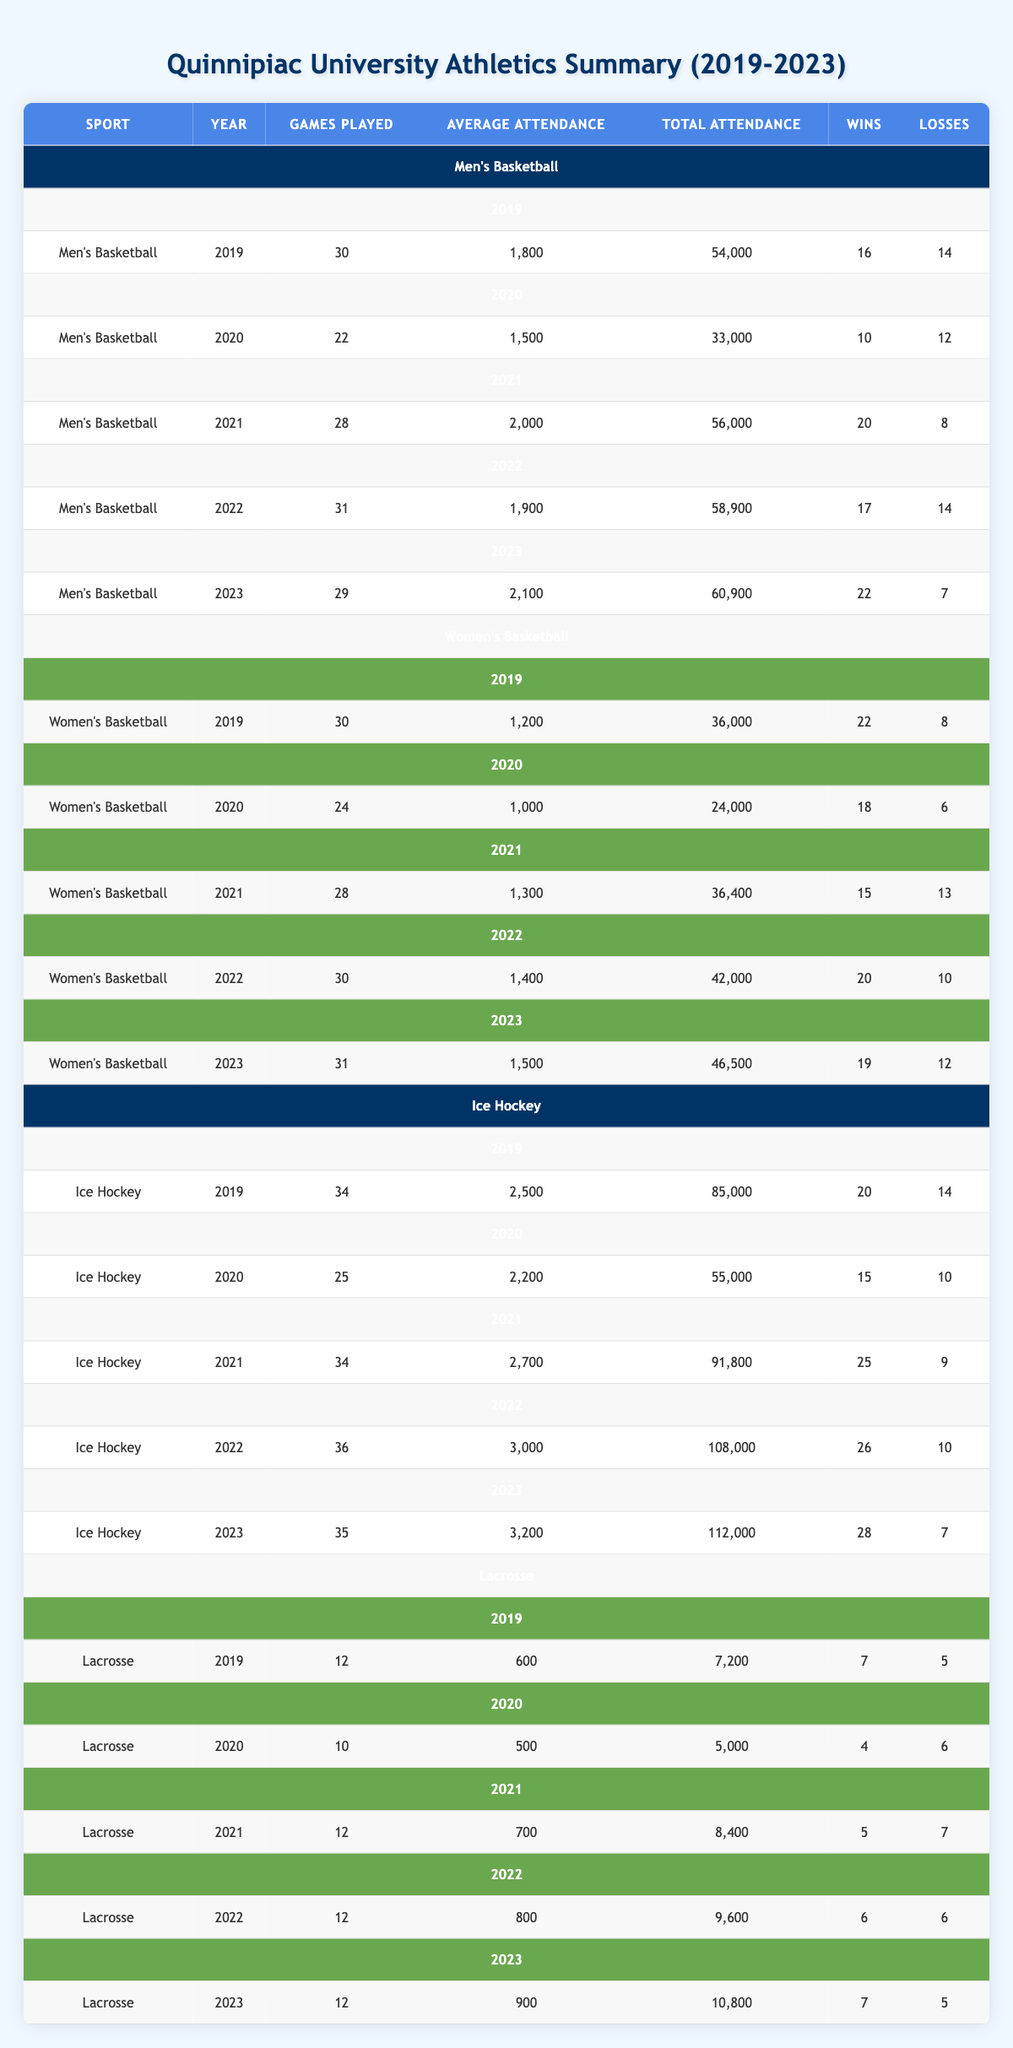What was the total attendance for Men's Basketball in 2021? In 2021, the total attendance for Men's Basketball was listed as 56,000 in the table.
Answer: 56,000 What was the average attendance for Ice Hockey in 2023? In the table, the average attendance for Ice Hockey in 2023 is stated as 3,200.
Answer: 3,200 Which sport had the highest total attendance in 2022? The total attendance for Ice Hockey in 2022 was 108,000, which is higher than Men's Basketball (58,900), Women's Basketball (42,000), and Lacrosse (9,600).
Answer: Ice Hockey How many more wins did the Women's Basketball team have in 2019 compared to 2020? In 2019, Women's Basketball had 22 wins, and in 2020, they had 18 wins. The difference in wins is 22 - 18 = 4.
Answer: 4 What is the average total attendance for Lacrosse over the five years? The total attendance for Lacrosse from 2019 to 2023 is (7,200 + 5,000 + 8,400 + 9,600 + 10,800) = 40,000. Dividing by 5 years gives an average of 40,000 / 5 = 8,000.
Answer: 8,000 Did the Men's Basketball team win more games than losses in 2022? The Men's Basketball team had 17 wins and 14 losses in 2022, which means they had more wins than losses.
Answer: Yes What was the trend in average attendance for Women's Basketball from 2019 to 2023? The average attendance for Women's Basketball from 2019 to 2023 was 1,200, 1,000, 1,300, 1,400, and 1,500, indicating an increasing trend over the five years.
Answer: Increasing trend How did the Ice Hockey team's average attendance in 2020 compare to 2022? Ice Hockey's average attendance in 2020 was 2,200, while in 2022 it was 3,000. The increase is calculated as 3,000 - 2,200 = 800.
Answer: 800 Which sport had the lowest total attendance in 2020? In 2020, Lacrosse had the lowest total attendance of 5,000 compared to Men’s Basketball (33,000), Women’s Basketball (24,000), and Ice Hockey (55,000).
Answer: Lacrosse What was the win-loss ratio for the Ice Hockey team in 2021? In 2021, the Ice Hockey team had 25 wins and 9 losses. The win-loss ratio is calculated as 25:9, which simplifies to approximately 2.78.
Answer: 2.78 